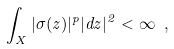Convert formula to latex. <formula><loc_0><loc_0><loc_500><loc_500>\int _ { X } | \sigma ( z ) | ^ { p } | d z | ^ { 2 } < \infty \ ,</formula> 